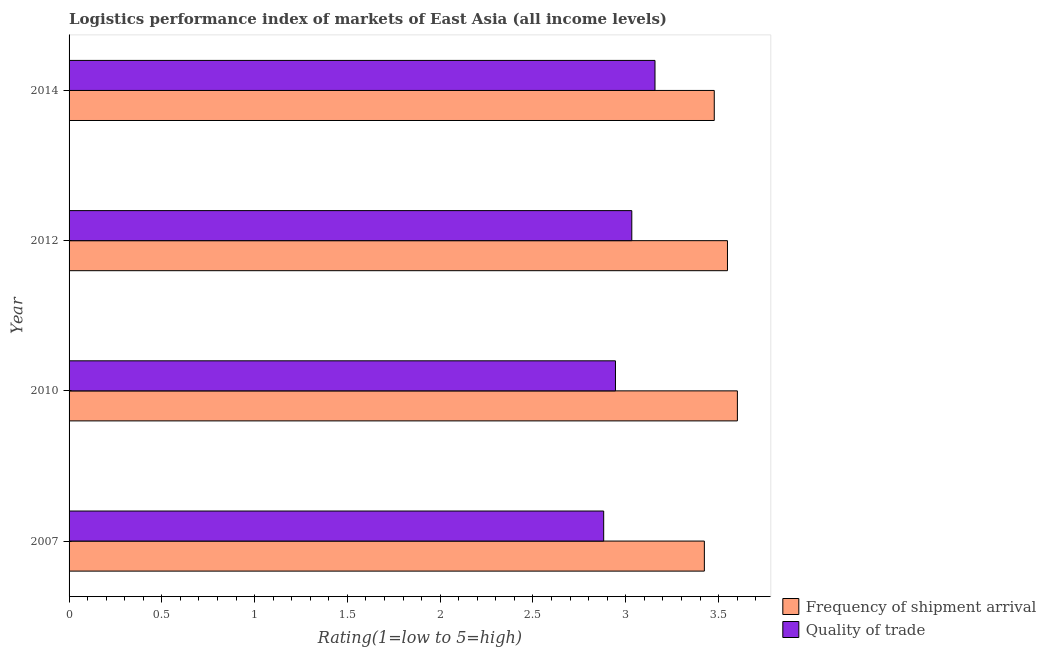How many different coloured bars are there?
Offer a very short reply. 2. How many groups of bars are there?
Provide a succinct answer. 4. What is the lpi quality of trade in 2014?
Ensure brevity in your answer.  3.16. Across all years, what is the maximum lpi of frequency of shipment arrival?
Keep it short and to the point. 3.6. Across all years, what is the minimum lpi quality of trade?
Provide a short and direct response. 2.88. What is the total lpi of frequency of shipment arrival in the graph?
Your answer should be compact. 14.05. What is the difference between the lpi quality of trade in 2010 and that in 2014?
Your answer should be compact. -0.21. What is the difference between the lpi quality of trade in 2010 and the lpi of frequency of shipment arrival in 2012?
Give a very brief answer. -0.6. What is the average lpi quality of trade per year?
Your answer should be very brief. 3. In the year 2012, what is the difference between the lpi quality of trade and lpi of frequency of shipment arrival?
Offer a very short reply. -0.52. In how many years, is the lpi of frequency of shipment arrival greater than 0.8 ?
Ensure brevity in your answer.  4. What is the ratio of the lpi quality of trade in 2010 to that in 2012?
Keep it short and to the point. 0.97. What is the difference between the highest and the lowest lpi of frequency of shipment arrival?
Make the answer very short. 0.18. In how many years, is the lpi quality of trade greater than the average lpi quality of trade taken over all years?
Provide a succinct answer. 2. Is the sum of the lpi of frequency of shipment arrival in 2007 and 2010 greater than the maximum lpi quality of trade across all years?
Make the answer very short. Yes. What does the 2nd bar from the top in 2010 represents?
Your response must be concise. Frequency of shipment arrival. What does the 1st bar from the bottom in 2012 represents?
Ensure brevity in your answer.  Frequency of shipment arrival. How many bars are there?
Your answer should be very brief. 8. How many years are there in the graph?
Give a very brief answer. 4. What is the difference between two consecutive major ticks on the X-axis?
Give a very brief answer. 0.5. Does the graph contain any zero values?
Your response must be concise. No. What is the title of the graph?
Ensure brevity in your answer.  Logistics performance index of markets of East Asia (all income levels). What is the label or title of the X-axis?
Your answer should be very brief. Rating(1=low to 5=high). What is the label or title of the Y-axis?
Offer a very short reply. Year. What is the Rating(1=low to 5=high) in Frequency of shipment arrival in 2007?
Make the answer very short. 3.42. What is the Rating(1=low to 5=high) of Quality of trade in 2007?
Provide a short and direct response. 2.88. What is the Rating(1=low to 5=high) of Frequency of shipment arrival in 2010?
Offer a very short reply. 3.6. What is the Rating(1=low to 5=high) of Quality of trade in 2010?
Provide a succinct answer. 2.94. What is the Rating(1=low to 5=high) of Frequency of shipment arrival in 2012?
Ensure brevity in your answer.  3.55. What is the Rating(1=low to 5=high) in Quality of trade in 2012?
Offer a terse response. 3.03. What is the Rating(1=low to 5=high) in Frequency of shipment arrival in 2014?
Offer a very short reply. 3.48. What is the Rating(1=low to 5=high) in Quality of trade in 2014?
Provide a short and direct response. 3.16. Across all years, what is the maximum Rating(1=low to 5=high) in Frequency of shipment arrival?
Your answer should be very brief. 3.6. Across all years, what is the maximum Rating(1=low to 5=high) of Quality of trade?
Make the answer very short. 3.16. Across all years, what is the minimum Rating(1=low to 5=high) in Frequency of shipment arrival?
Provide a short and direct response. 3.42. Across all years, what is the minimum Rating(1=low to 5=high) in Quality of trade?
Your answer should be compact. 2.88. What is the total Rating(1=low to 5=high) of Frequency of shipment arrival in the graph?
Provide a succinct answer. 14.05. What is the total Rating(1=low to 5=high) of Quality of trade in the graph?
Provide a short and direct response. 12.02. What is the difference between the Rating(1=low to 5=high) in Frequency of shipment arrival in 2007 and that in 2010?
Offer a terse response. -0.18. What is the difference between the Rating(1=low to 5=high) in Quality of trade in 2007 and that in 2010?
Offer a terse response. -0.06. What is the difference between the Rating(1=low to 5=high) in Frequency of shipment arrival in 2007 and that in 2012?
Keep it short and to the point. -0.12. What is the difference between the Rating(1=low to 5=high) in Quality of trade in 2007 and that in 2012?
Ensure brevity in your answer.  -0.15. What is the difference between the Rating(1=low to 5=high) in Frequency of shipment arrival in 2007 and that in 2014?
Offer a terse response. -0.05. What is the difference between the Rating(1=low to 5=high) of Quality of trade in 2007 and that in 2014?
Provide a succinct answer. -0.28. What is the difference between the Rating(1=low to 5=high) in Frequency of shipment arrival in 2010 and that in 2012?
Keep it short and to the point. 0.05. What is the difference between the Rating(1=low to 5=high) of Quality of trade in 2010 and that in 2012?
Give a very brief answer. -0.09. What is the difference between the Rating(1=low to 5=high) of Frequency of shipment arrival in 2010 and that in 2014?
Ensure brevity in your answer.  0.12. What is the difference between the Rating(1=low to 5=high) in Quality of trade in 2010 and that in 2014?
Offer a terse response. -0.21. What is the difference between the Rating(1=low to 5=high) in Frequency of shipment arrival in 2012 and that in 2014?
Keep it short and to the point. 0.07. What is the difference between the Rating(1=low to 5=high) of Quality of trade in 2012 and that in 2014?
Offer a very short reply. -0.12. What is the difference between the Rating(1=low to 5=high) of Frequency of shipment arrival in 2007 and the Rating(1=low to 5=high) of Quality of trade in 2010?
Offer a very short reply. 0.48. What is the difference between the Rating(1=low to 5=high) in Frequency of shipment arrival in 2007 and the Rating(1=low to 5=high) in Quality of trade in 2012?
Offer a very short reply. 0.39. What is the difference between the Rating(1=low to 5=high) of Frequency of shipment arrival in 2007 and the Rating(1=low to 5=high) of Quality of trade in 2014?
Offer a very short reply. 0.27. What is the difference between the Rating(1=low to 5=high) of Frequency of shipment arrival in 2010 and the Rating(1=low to 5=high) of Quality of trade in 2012?
Offer a terse response. 0.57. What is the difference between the Rating(1=low to 5=high) of Frequency of shipment arrival in 2010 and the Rating(1=low to 5=high) of Quality of trade in 2014?
Offer a terse response. 0.44. What is the difference between the Rating(1=low to 5=high) in Frequency of shipment arrival in 2012 and the Rating(1=low to 5=high) in Quality of trade in 2014?
Your answer should be very brief. 0.39. What is the average Rating(1=low to 5=high) in Frequency of shipment arrival per year?
Ensure brevity in your answer.  3.51. What is the average Rating(1=low to 5=high) of Quality of trade per year?
Keep it short and to the point. 3. In the year 2007, what is the difference between the Rating(1=low to 5=high) in Frequency of shipment arrival and Rating(1=low to 5=high) in Quality of trade?
Ensure brevity in your answer.  0.54. In the year 2010, what is the difference between the Rating(1=low to 5=high) in Frequency of shipment arrival and Rating(1=low to 5=high) in Quality of trade?
Ensure brevity in your answer.  0.66. In the year 2012, what is the difference between the Rating(1=low to 5=high) in Frequency of shipment arrival and Rating(1=low to 5=high) in Quality of trade?
Your answer should be compact. 0.52. In the year 2014, what is the difference between the Rating(1=low to 5=high) of Frequency of shipment arrival and Rating(1=low to 5=high) of Quality of trade?
Keep it short and to the point. 0.32. What is the ratio of the Rating(1=low to 5=high) of Frequency of shipment arrival in 2007 to that in 2010?
Your answer should be very brief. 0.95. What is the ratio of the Rating(1=low to 5=high) in Quality of trade in 2007 to that in 2010?
Give a very brief answer. 0.98. What is the ratio of the Rating(1=low to 5=high) in Frequency of shipment arrival in 2007 to that in 2012?
Make the answer very short. 0.96. What is the ratio of the Rating(1=low to 5=high) in Frequency of shipment arrival in 2007 to that in 2014?
Keep it short and to the point. 0.98. What is the ratio of the Rating(1=low to 5=high) of Quality of trade in 2007 to that in 2014?
Provide a succinct answer. 0.91. What is the ratio of the Rating(1=low to 5=high) of Frequency of shipment arrival in 2010 to that in 2012?
Offer a terse response. 1.02. What is the ratio of the Rating(1=low to 5=high) of Frequency of shipment arrival in 2010 to that in 2014?
Keep it short and to the point. 1.04. What is the ratio of the Rating(1=low to 5=high) of Quality of trade in 2010 to that in 2014?
Ensure brevity in your answer.  0.93. What is the ratio of the Rating(1=low to 5=high) in Frequency of shipment arrival in 2012 to that in 2014?
Offer a terse response. 1.02. What is the ratio of the Rating(1=low to 5=high) of Quality of trade in 2012 to that in 2014?
Keep it short and to the point. 0.96. What is the difference between the highest and the second highest Rating(1=low to 5=high) of Frequency of shipment arrival?
Your response must be concise. 0.05. What is the difference between the highest and the second highest Rating(1=low to 5=high) in Quality of trade?
Give a very brief answer. 0.12. What is the difference between the highest and the lowest Rating(1=low to 5=high) of Frequency of shipment arrival?
Your answer should be compact. 0.18. What is the difference between the highest and the lowest Rating(1=low to 5=high) of Quality of trade?
Your answer should be very brief. 0.28. 